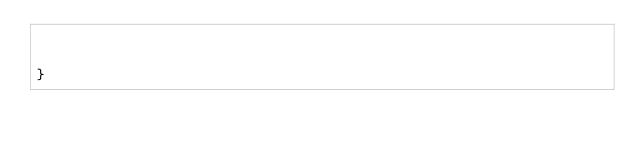<code> <loc_0><loc_0><loc_500><loc_500><_CSS_>    
    
}</code> 